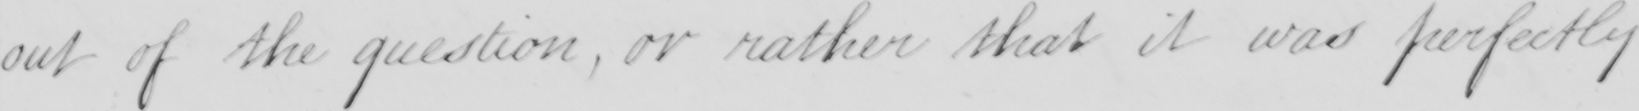Please transcribe the handwritten text in this image. out of the question, or rather that it was perfectly 